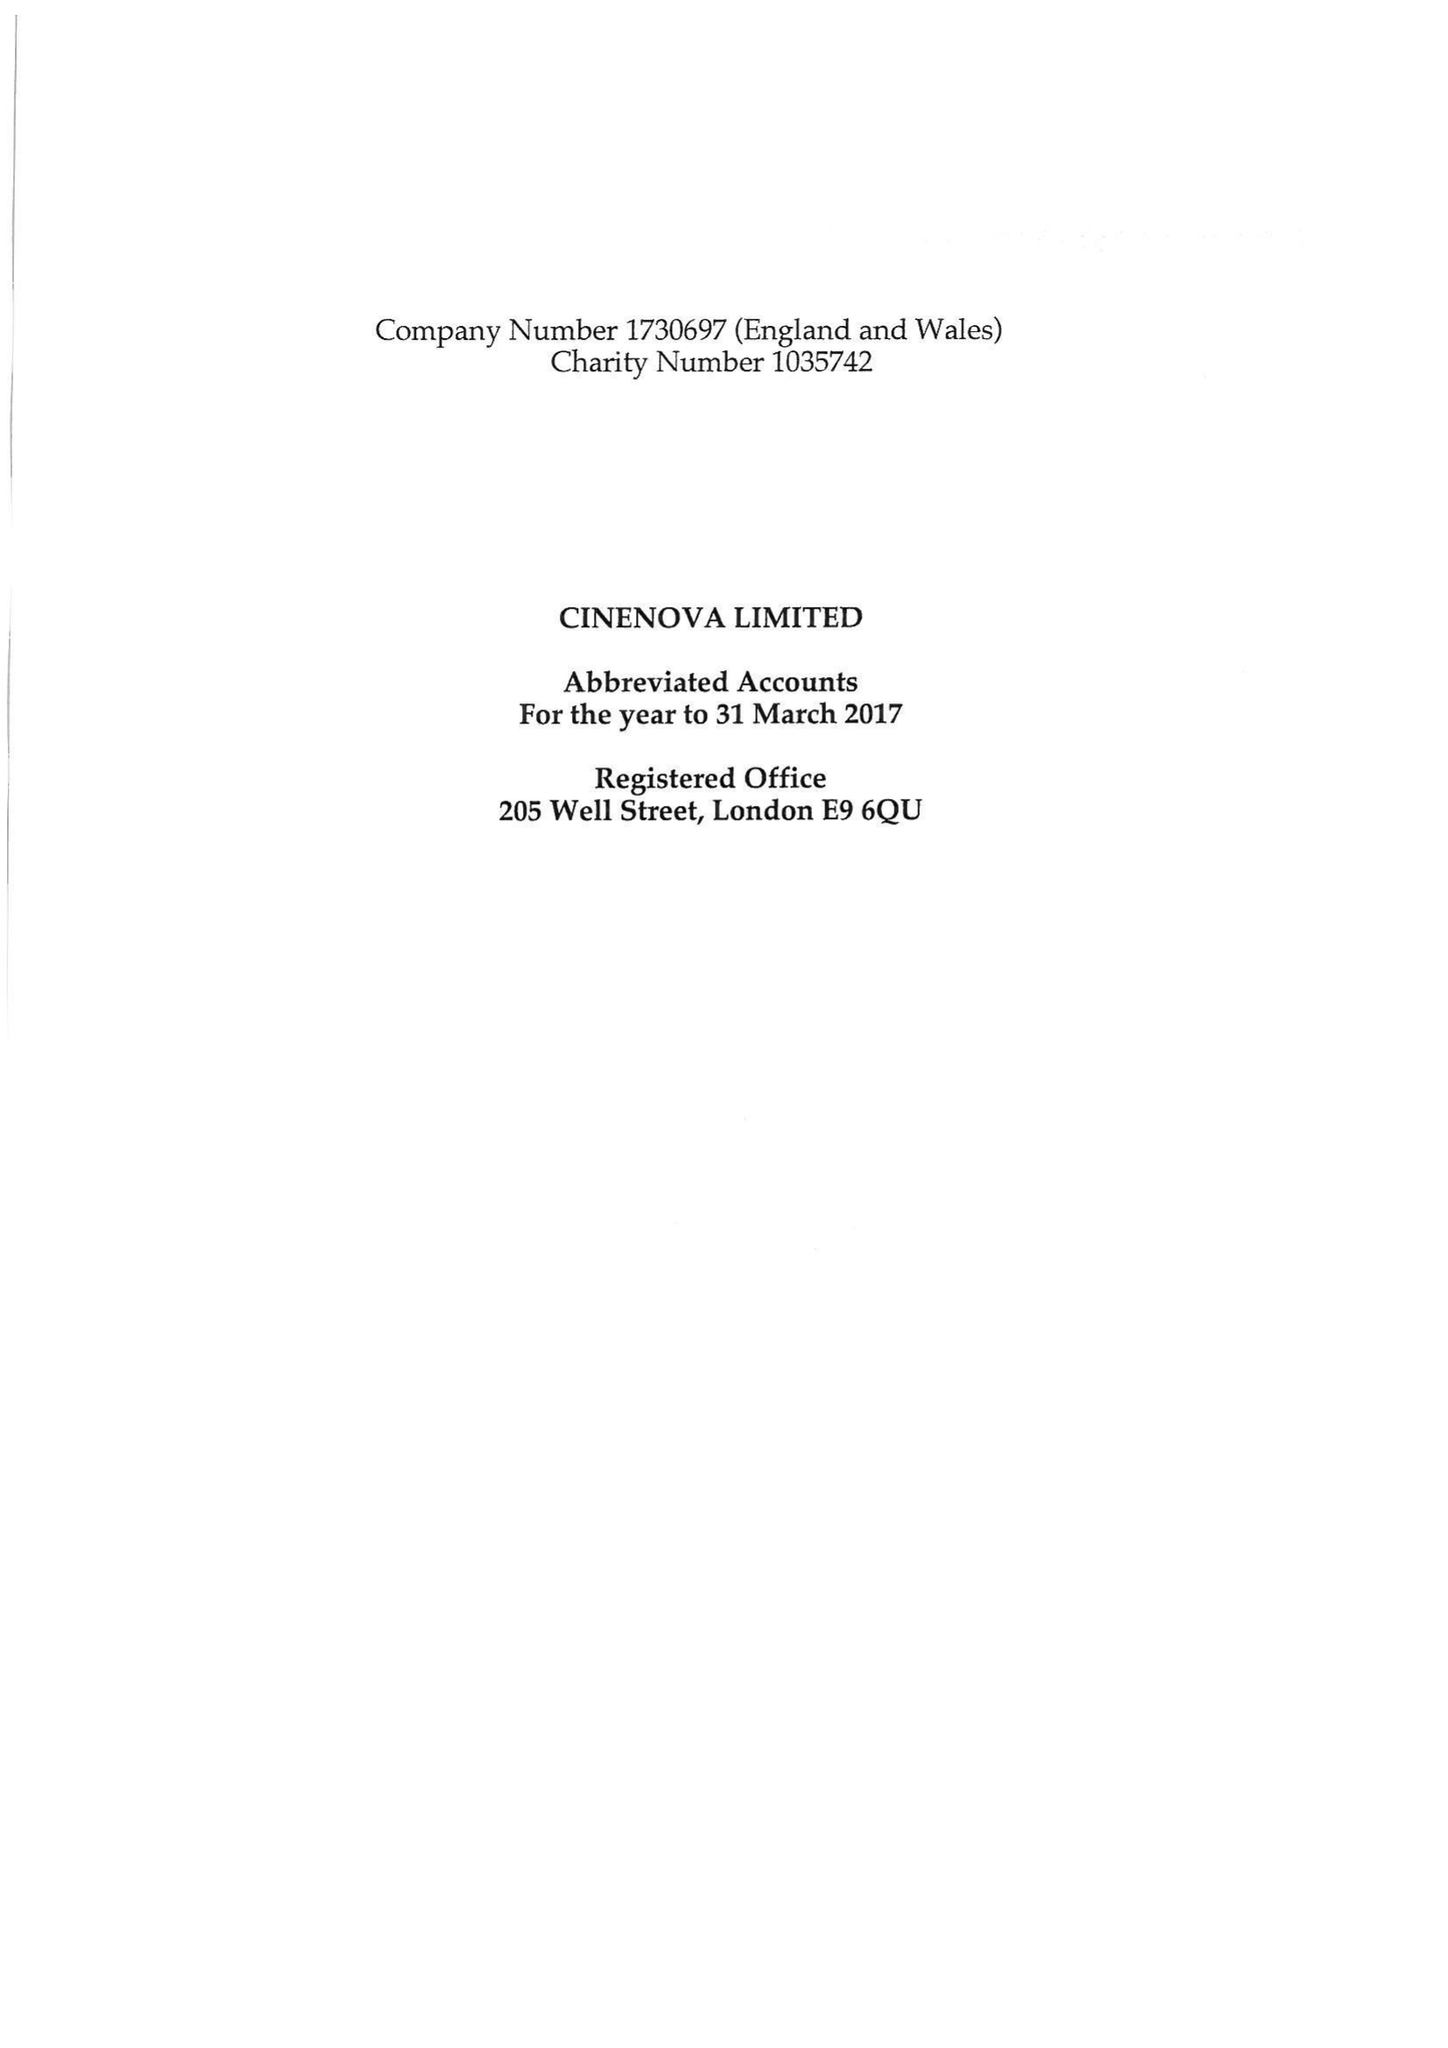What is the value for the report_date?
Answer the question using a single word or phrase. 2017-03-31 